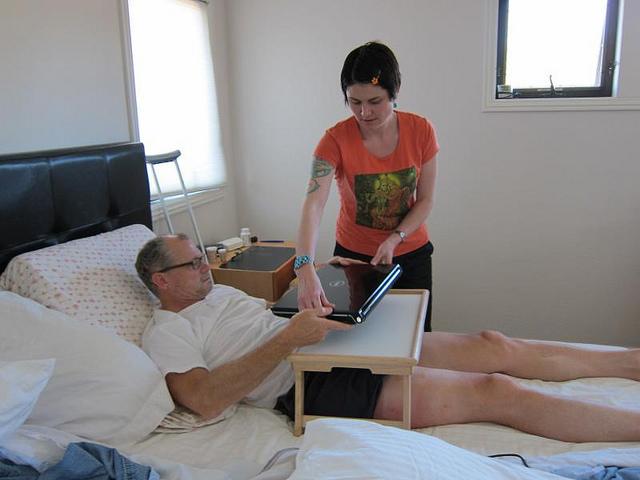Is the man in a hospital?
Be succinct. No. What does this man have?
Concise answer only. Laptop. Is the person injured?
Keep it brief. Yes. 